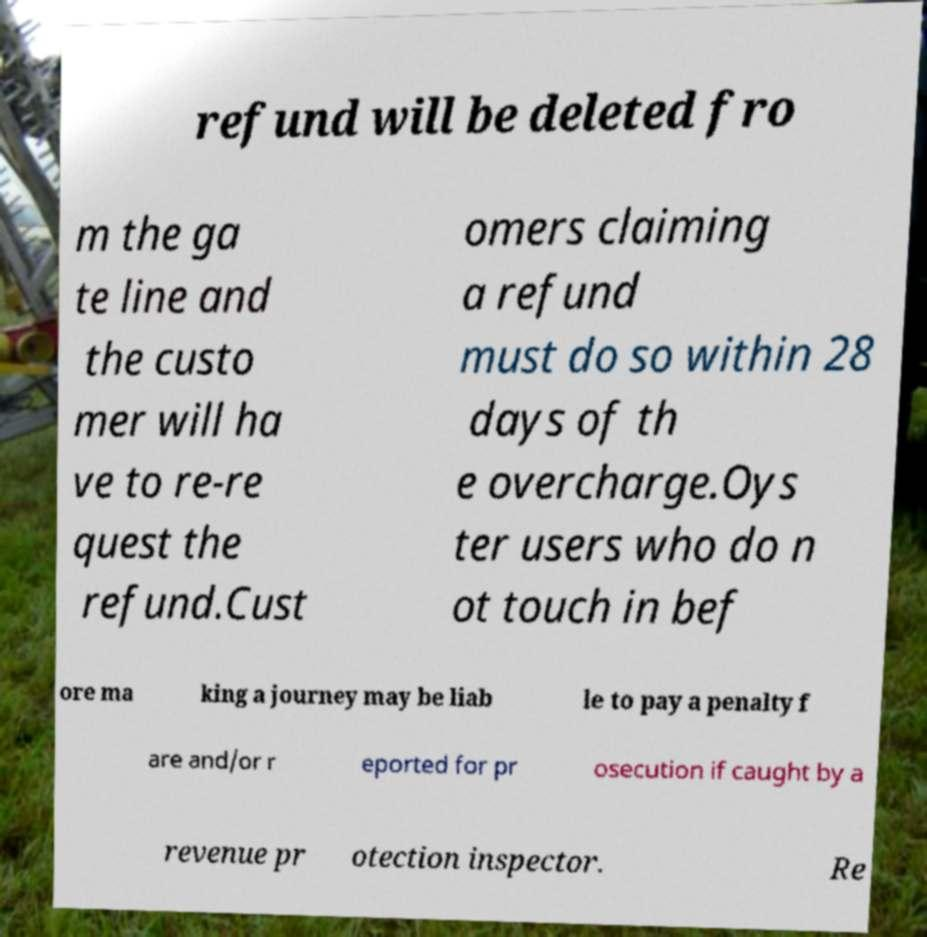Could you extract and type out the text from this image? refund will be deleted fro m the ga te line and the custo mer will ha ve to re-re quest the refund.Cust omers claiming a refund must do so within 28 days of th e overcharge.Oys ter users who do n ot touch in bef ore ma king a journey may be liab le to pay a penalty f are and/or r eported for pr osecution if caught by a revenue pr otection inspector. Re 